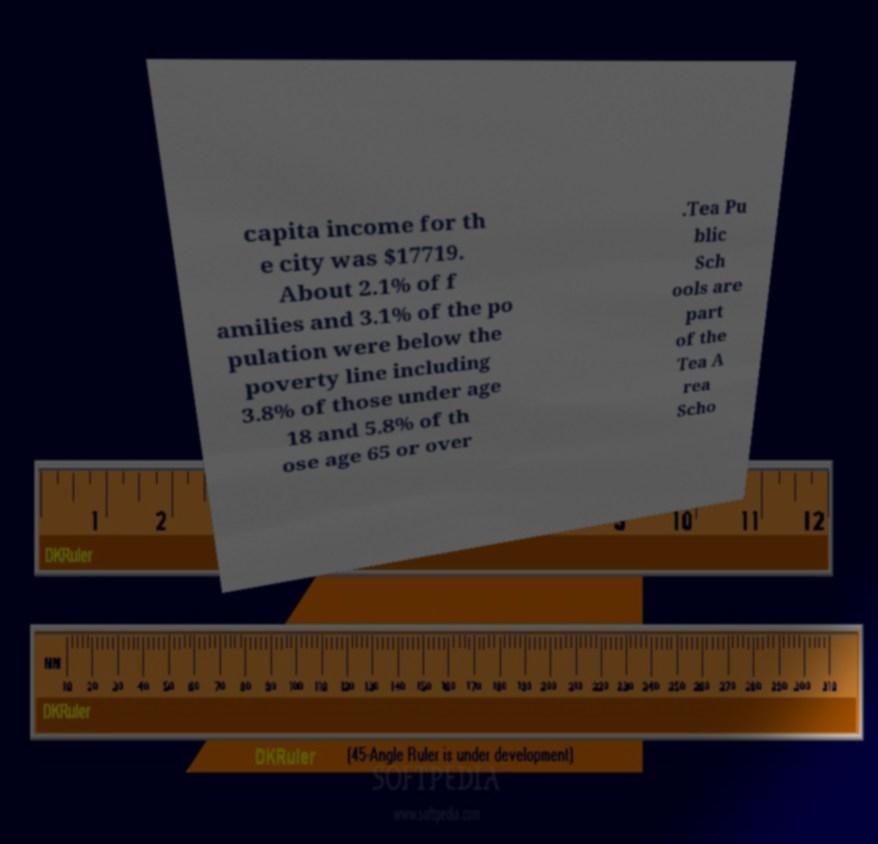For documentation purposes, I need the text within this image transcribed. Could you provide that? capita income for th e city was $17719. About 2.1% of f amilies and 3.1% of the po pulation were below the poverty line including 3.8% of those under age 18 and 5.8% of th ose age 65 or over .Tea Pu blic Sch ools are part of the Tea A rea Scho 